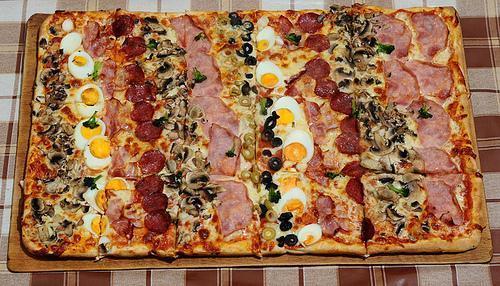How many meat toppings are there?
Give a very brief answer. 2. 